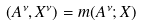<formula> <loc_0><loc_0><loc_500><loc_500>( A ^ { \nu } , X ^ { \nu } ) = m ( A ^ { \nu } ; X )</formula> 